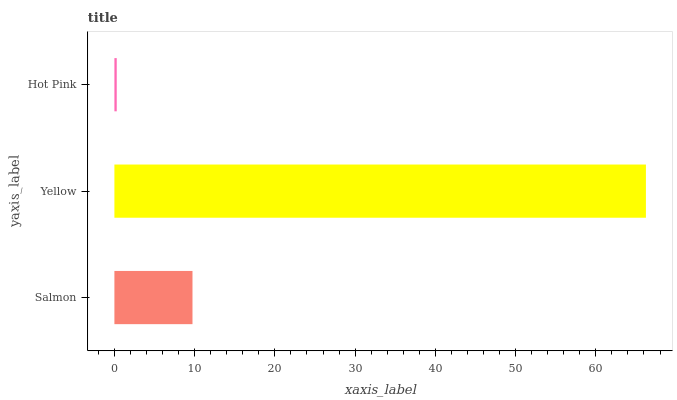Is Hot Pink the minimum?
Answer yes or no. Yes. Is Yellow the maximum?
Answer yes or no. Yes. Is Yellow the minimum?
Answer yes or no. No. Is Hot Pink the maximum?
Answer yes or no. No. Is Yellow greater than Hot Pink?
Answer yes or no. Yes. Is Hot Pink less than Yellow?
Answer yes or no. Yes. Is Hot Pink greater than Yellow?
Answer yes or no. No. Is Yellow less than Hot Pink?
Answer yes or no. No. Is Salmon the high median?
Answer yes or no. Yes. Is Salmon the low median?
Answer yes or no. Yes. Is Yellow the high median?
Answer yes or no. No. Is Hot Pink the low median?
Answer yes or no. No. 